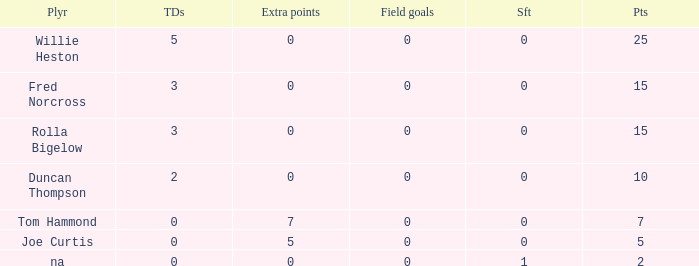Which points is the lowest one that has touchdowns fewer than 2, and an extra points of 7, and a field goals less than 0? None. 